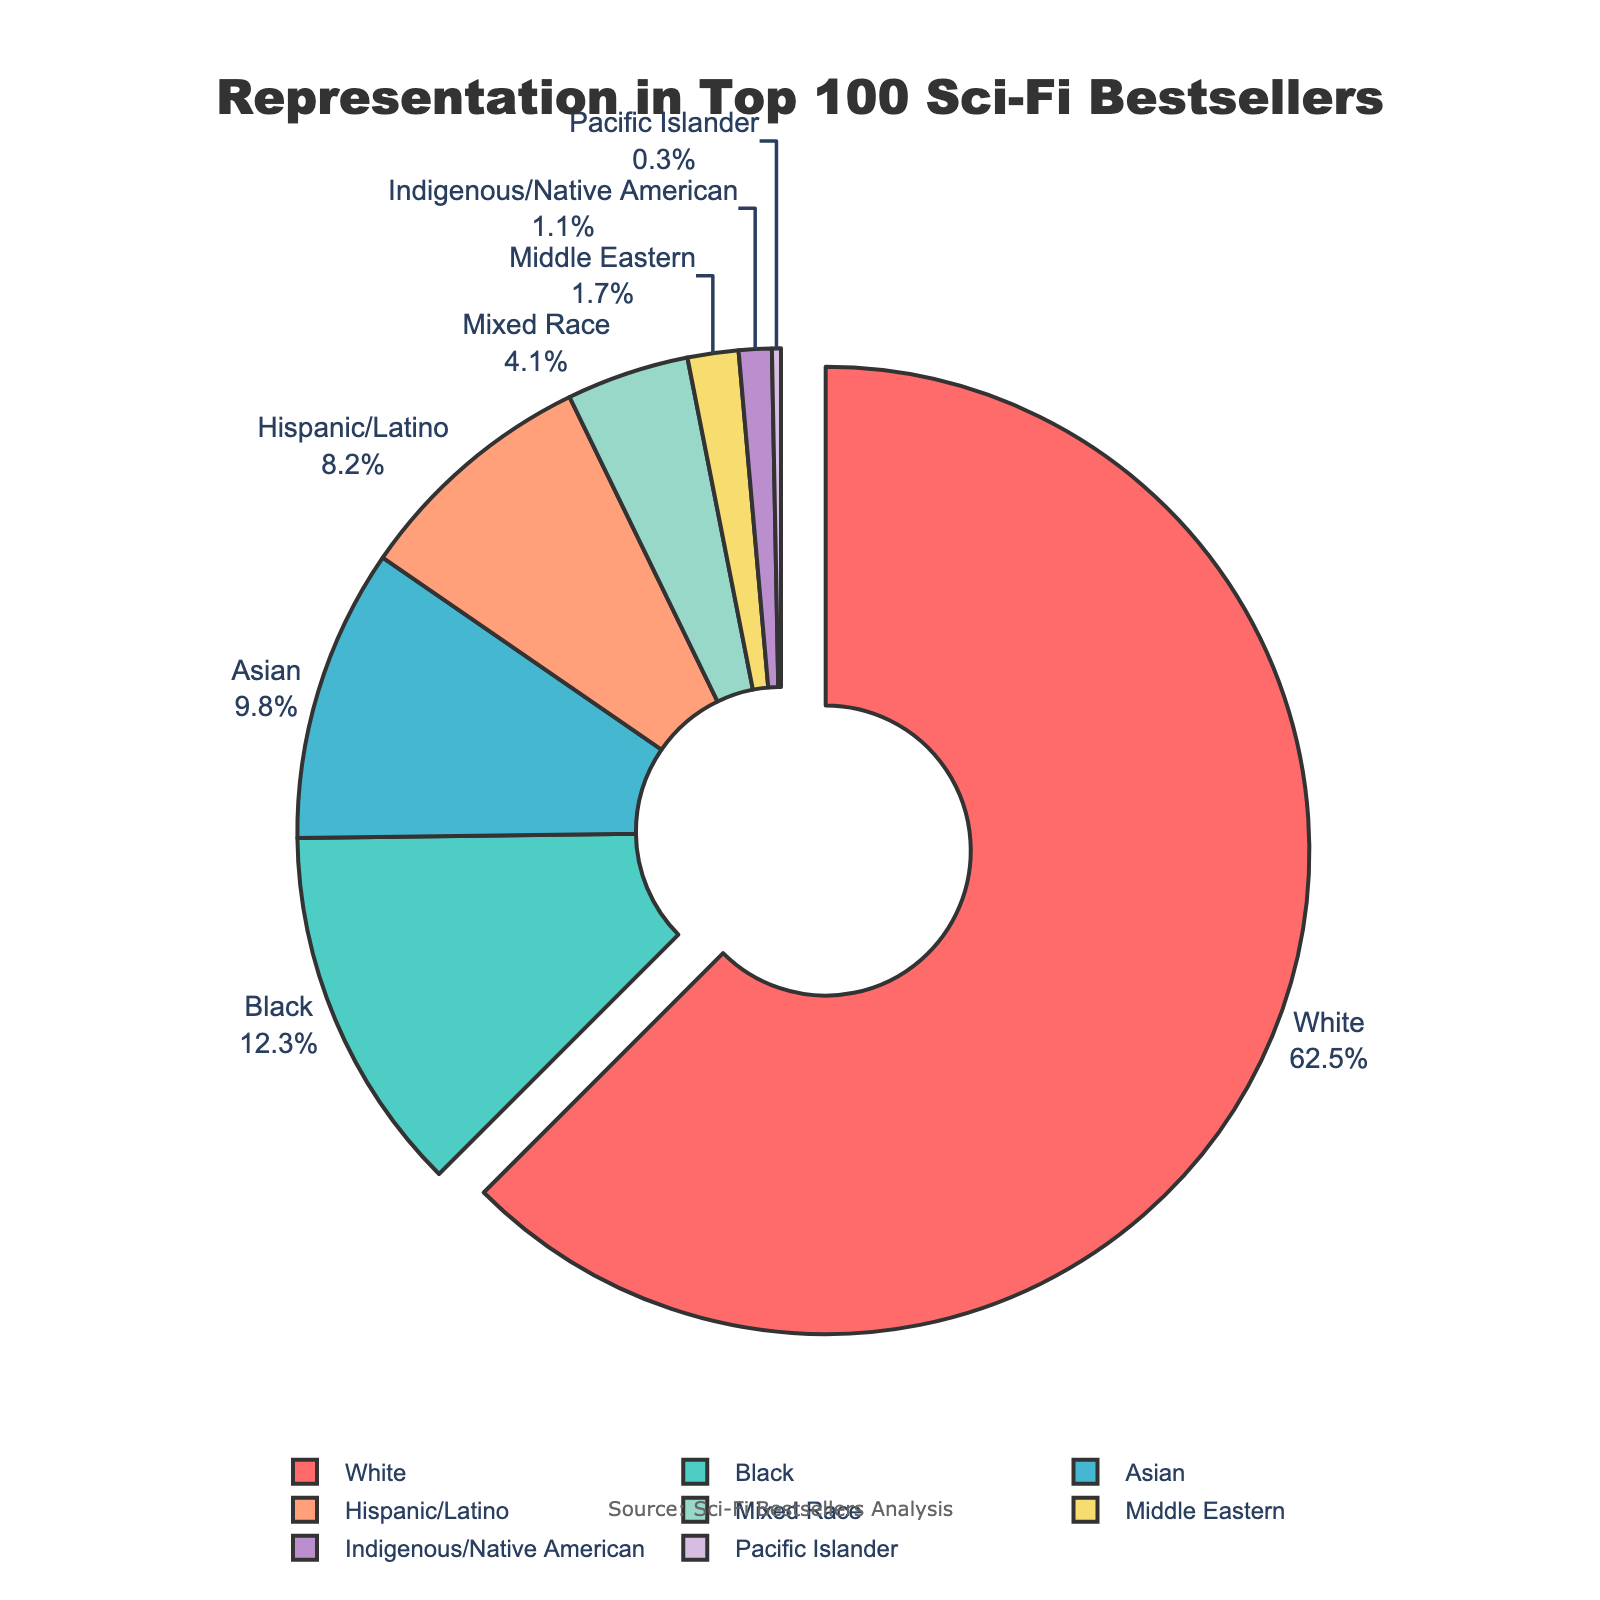What percentage of top 100 sci-fi bestsellers were written by authors who identify as Black? Look at the pie chart segment labeled "Black" and read the percentage shown.
Answer: 12.3% What is the combined percentage of top 100 sci-fi bestsellers written by Hispanic/Latino and Mixed Race authors? Add the percentages of Hispanic/Latino (8.2%) and Mixed Race (4.1%) authors.
Answer: 12.3% Which group has a smaller representation, Middle Eastern or Pacific Islander? Compare the pie chart segments labeled "Middle Eastern" (1.7%) and "Pacific Islander" (0.3%) to see which percentage is smaller.
Answer: Pacific Islander How much larger is the representation of White authors compared to Asian authors? Subtract the percentage of Asian authors (9.8%) from the percentage of White authors (62.5%).
Answer: 52.7% If you combine the percentages of all groups except White authors, what is the total representation? Add the percentages of Black, Asian, Hispanic/Latino, Mixed Race, Middle Eastern, Indigenous/Native American, and Pacific Islander authors: 12.3% + 9.8% + 8.2% + 4.1% + 1.7% + 1.1% + 0.3%.
Answer: 37.5% Which group's representation is indicated by the largest pie slice, and by how much does it exceed the next largest group? Identify the largest pie slice labeled "White" (62.5%) and compare it to the next largest group labeled "Black" (12.3%). Subtract the percentage of Black authors from White authors.
Answer: White, 50.2% What are the visual attributes that make it easy to identify the largest group in the pie chart? The largest group ("White") is visually identifiable by the largest pie slice being pulled out slightly from the pie chart, and the segment has a bright red color.
Answer: Largest pie slice, pulled out slightly, bright red color 